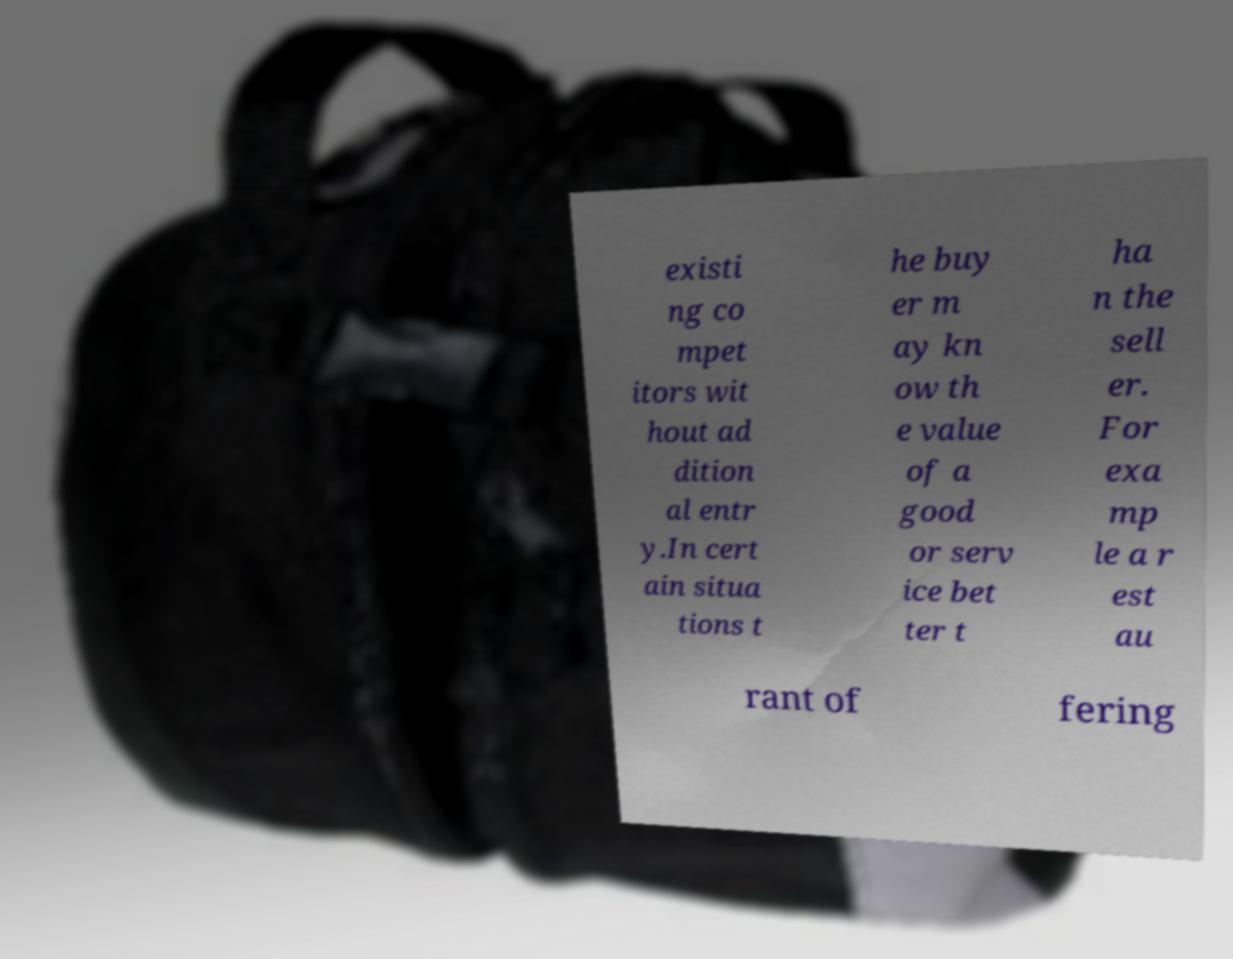There's text embedded in this image that I need extracted. Can you transcribe it verbatim? existi ng co mpet itors wit hout ad dition al entr y.In cert ain situa tions t he buy er m ay kn ow th e value of a good or serv ice bet ter t ha n the sell er. For exa mp le a r est au rant of fering 